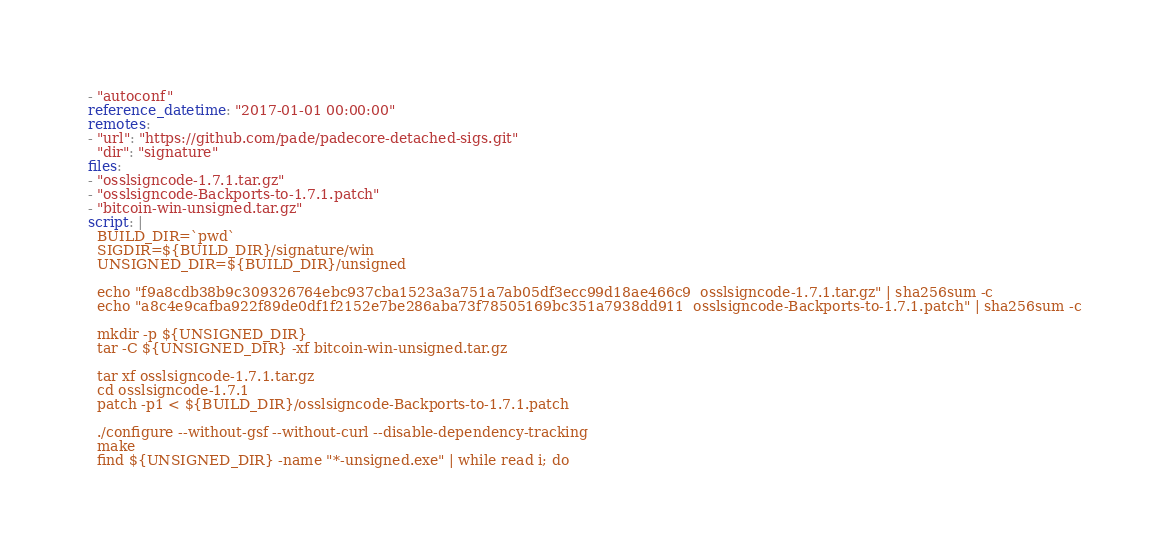<code> <loc_0><loc_0><loc_500><loc_500><_YAML_>- "autoconf"
reference_datetime: "2017-01-01 00:00:00"
remotes:
- "url": "https://github.com/pade/padecore-detached-sigs.git"
  "dir": "signature"
files:
- "osslsigncode-1.7.1.tar.gz"
- "osslsigncode-Backports-to-1.7.1.patch"
- "bitcoin-win-unsigned.tar.gz"
script: |
  BUILD_DIR=`pwd`
  SIGDIR=${BUILD_DIR}/signature/win
  UNSIGNED_DIR=${BUILD_DIR}/unsigned

  echo "f9a8cdb38b9c309326764ebc937cba1523a3a751a7ab05df3ecc99d18ae466c9  osslsigncode-1.7.1.tar.gz" | sha256sum -c
  echo "a8c4e9cafba922f89de0df1f2152e7be286aba73f78505169bc351a7938dd911  osslsigncode-Backports-to-1.7.1.patch" | sha256sum -c

  mkdir -p ${UNSIGNED_DIR}
  tar -C ${UNSIGNED_DIR} -xf bitcoin-win-unsigned.tar.gz

  tar xf osslsigncode-1.7.1.tar.gz
  cd osslsigncode-1.7.1
  patch -p1 < ${BUILD_DIR}/osslsigncode-Backports-to-1.7.1.patch

  ./configure --without-gsf --without-curl --disable-dependency-tracking
  make
  find ${UNSIGNED_DIR} -name "*-unsigned.exe" | while read i; do</code> 